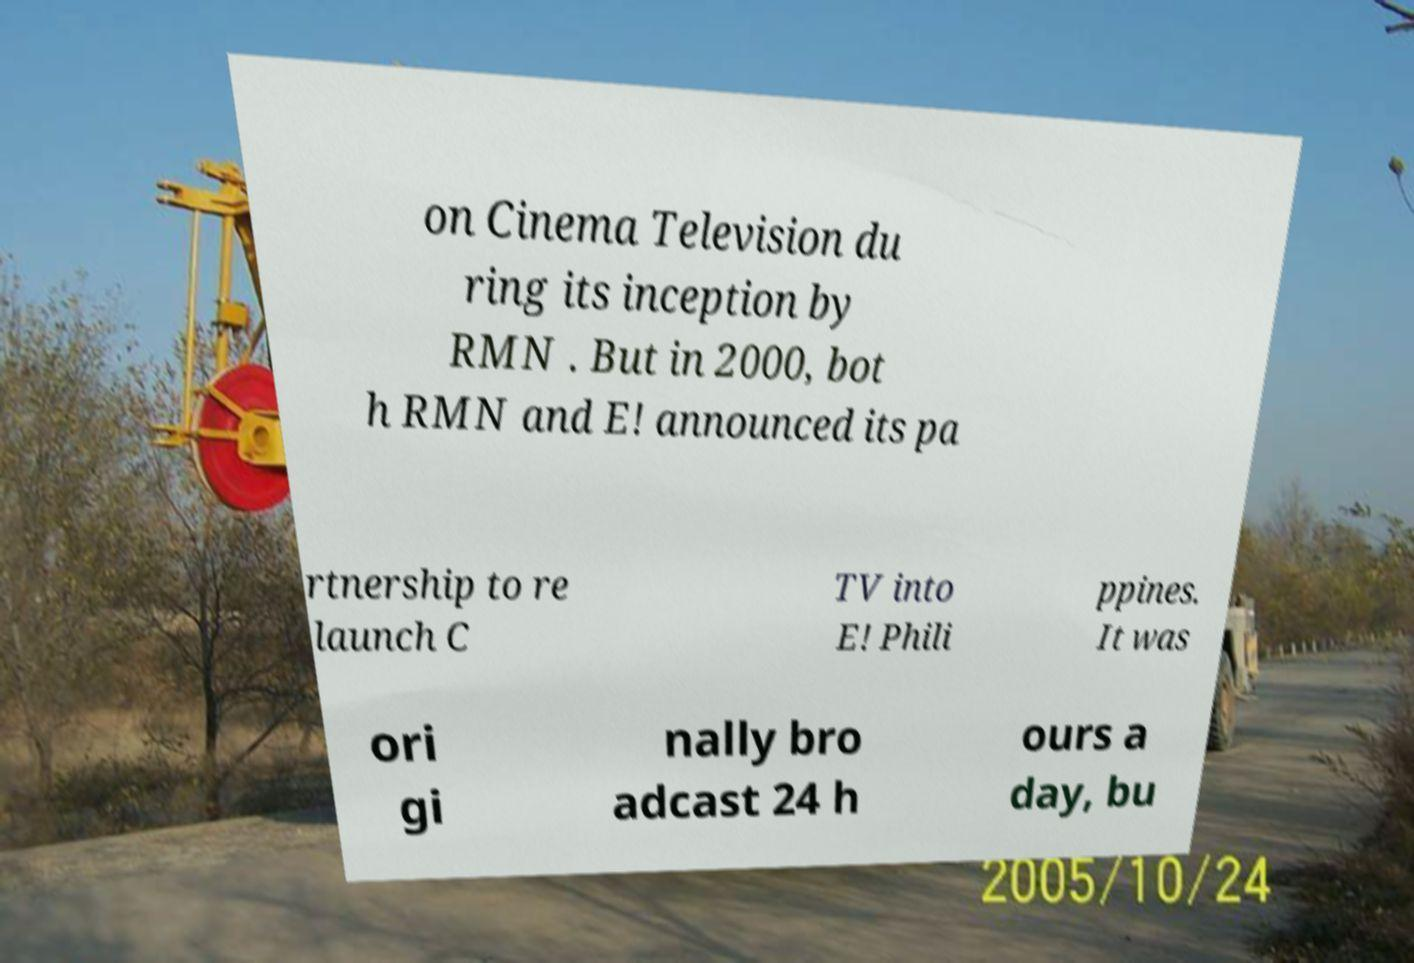There's text embedded in this image that I need extracted. Can you transcribe it verbatim? on Cinema Television du ring its inception by RMN . But in 2000, bot h RMN and E! announced its pa rtnership to re launch C TV into E! Phili ppines. It was ori gi nally bro adcast 24 h ours a day, bu 